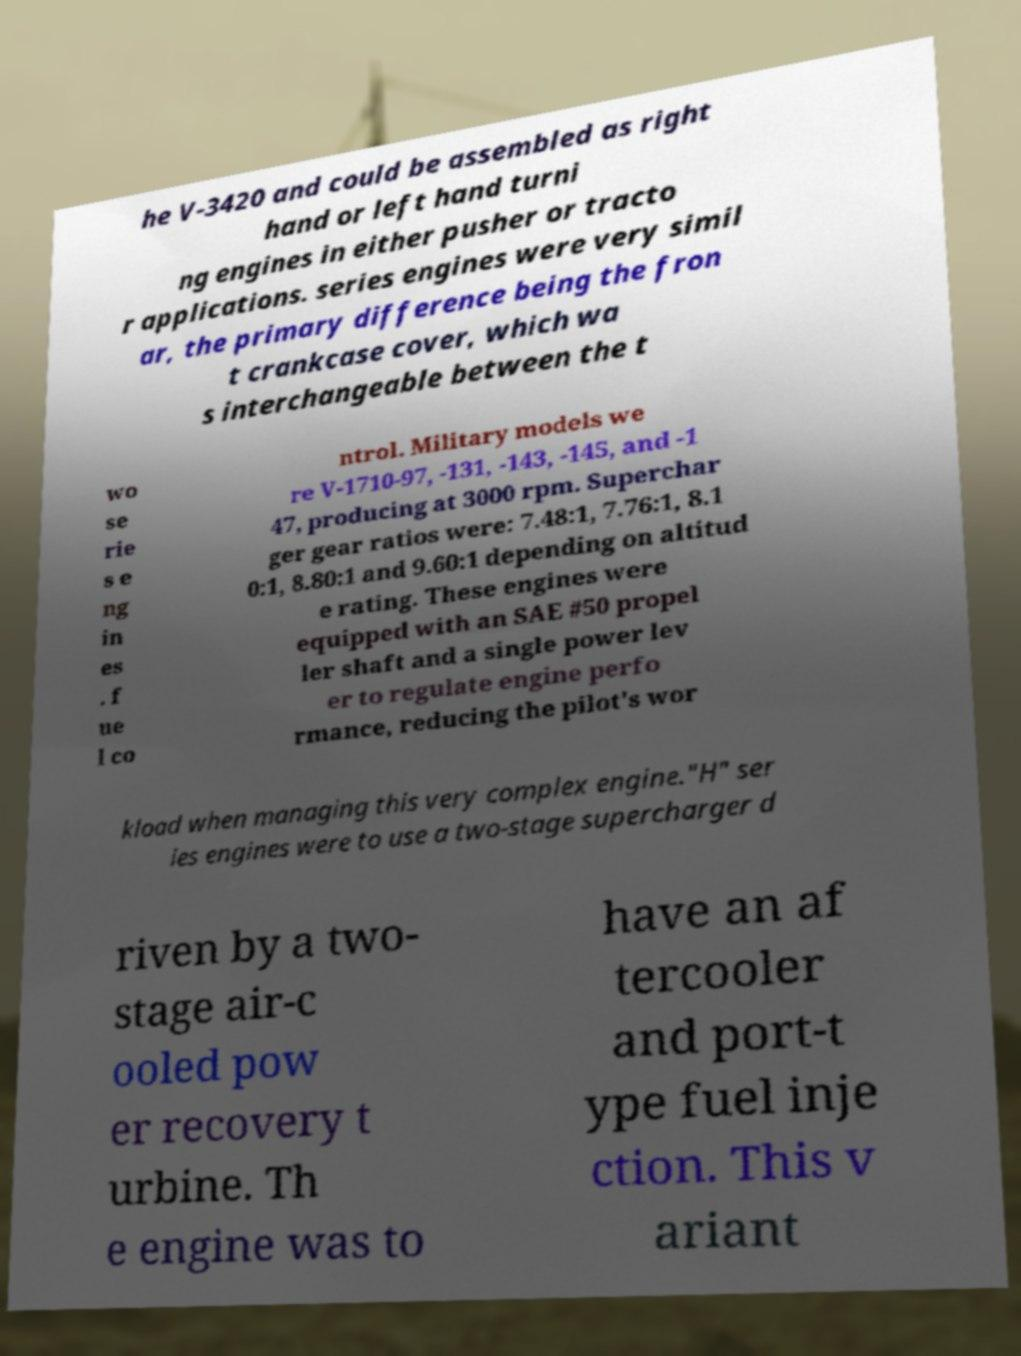For documentation purposes, I need the text within this image transcribed. Could you provide that? he V-3420 and could be assembled as right hand or left hand turni ng engines in either pusher or tracto r applications. series engines were very simil ar, the primary difference being the fron t crankcase cover, which wa s interchangeable between the t wo se rie s e ng in es . f ue l co ntrol. Military models we re V-1710-97, -131, -143, -145, and -1 47, producing at 3000 rpm. Superchar ger gear ratios were: 7.48:1, 7.76:1, 8.1 0:1, 8.80:1 and 9.60:1 depending on altitud e rating. These engines were equipped with an SAE #50 propel ler shaft and a single power lev er to regulate engine perfo rmance, reducing the pilot's wor kload when managing this very complex engine."H" ser ies engines were to use a two-stage supercharger d riven by a two- stage air-c ooled pow er recovery t urbine. Th e engine was to have an af tercooler and port-t ype fuel inje ction. This v ariant 